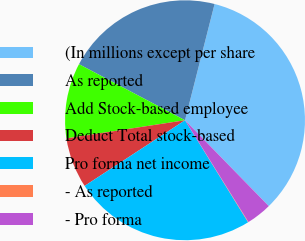Convert chart. <chart><loc_0><loc_0><loc_500><loc_500><pie_chart><fcel>(In millions except per share<fcel>As reported<fcel>Add Stock-based employee<fcel>Deduct Total stock-based<fcel>Pro forma net income<fcel>- As reported<fcel>- Pro forma<nl><fcel>33.73%<fcel>21.22%<fcel>10.16%<fcel>6.8%<fcel>24.59%<fcel>0.06%<fcel>3.43%<nl></chart> 